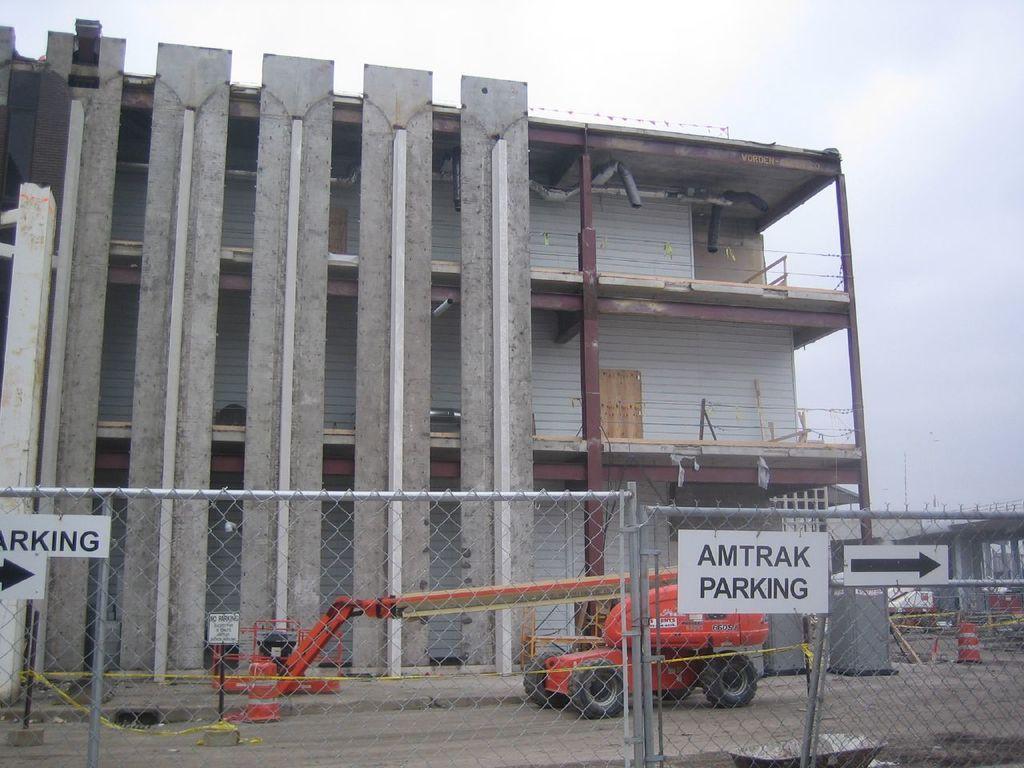Could you give a brief overview of what you see in this image? In this image we can see there is a building, in front of the building there is a JCP. In the foreground of the image there is a net fencing and some boards attached to it. In the background there is a sky. 